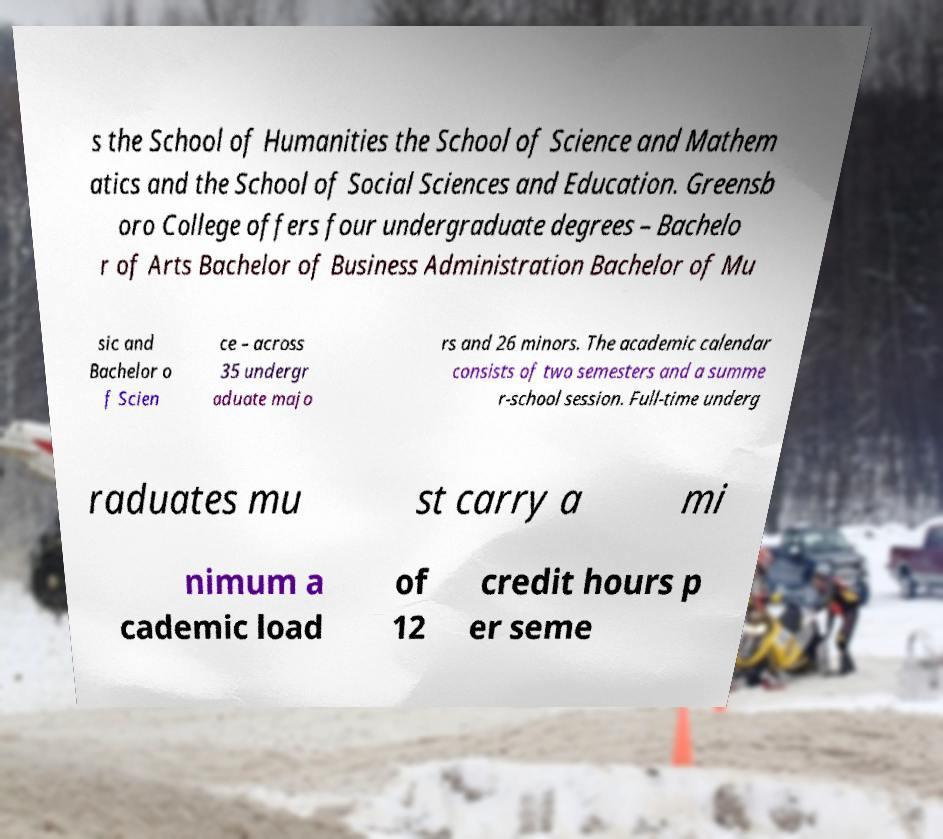For documentation purposes, I need the text within this image transcribed. Could you provide that? s the School of Humanities the School of Science and Mathem atics and the School of Social Sciences and Education. Greensb oro College offers four undergraduate degrees – Bachelo r of Arts Bachelor of Business Administration Bachelor of Mu sic and Bachelor o f Scien ce – across 35 undergr aduate majo rs and 26 minors. The academic calendar consists of two semesters and a summe r-school session. Full-time underg raduates mu st carry a mi nimum a cademic load of 12 credit hours p er seme 